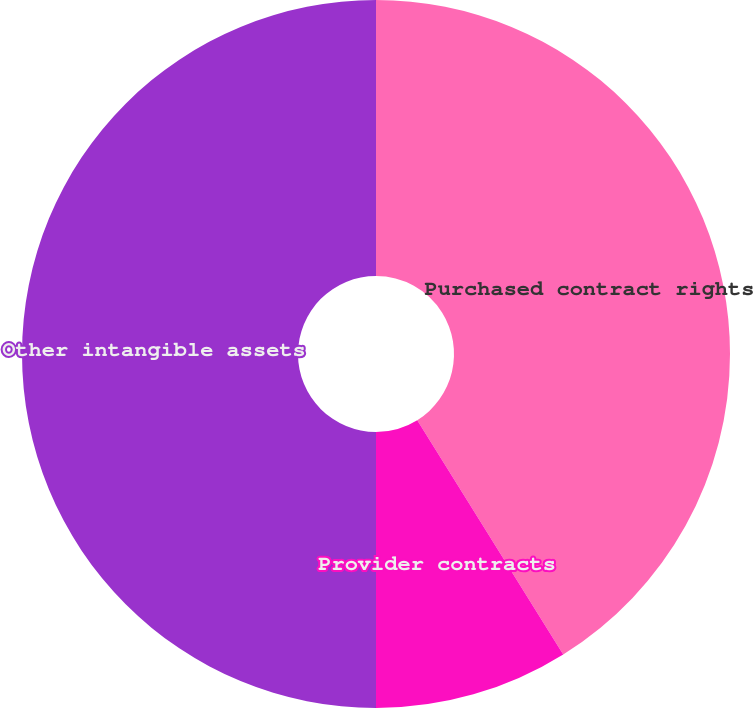<chart> <loc_0><loc_0><loc_500><loc_500><pie_chart><fcel>Purchased contract rights<fcel>Provider contracts<fcel>Other intangible assets<nl><fcel>41.13%<fcel>8.87%<fcel>50.0%<nl></chart> 